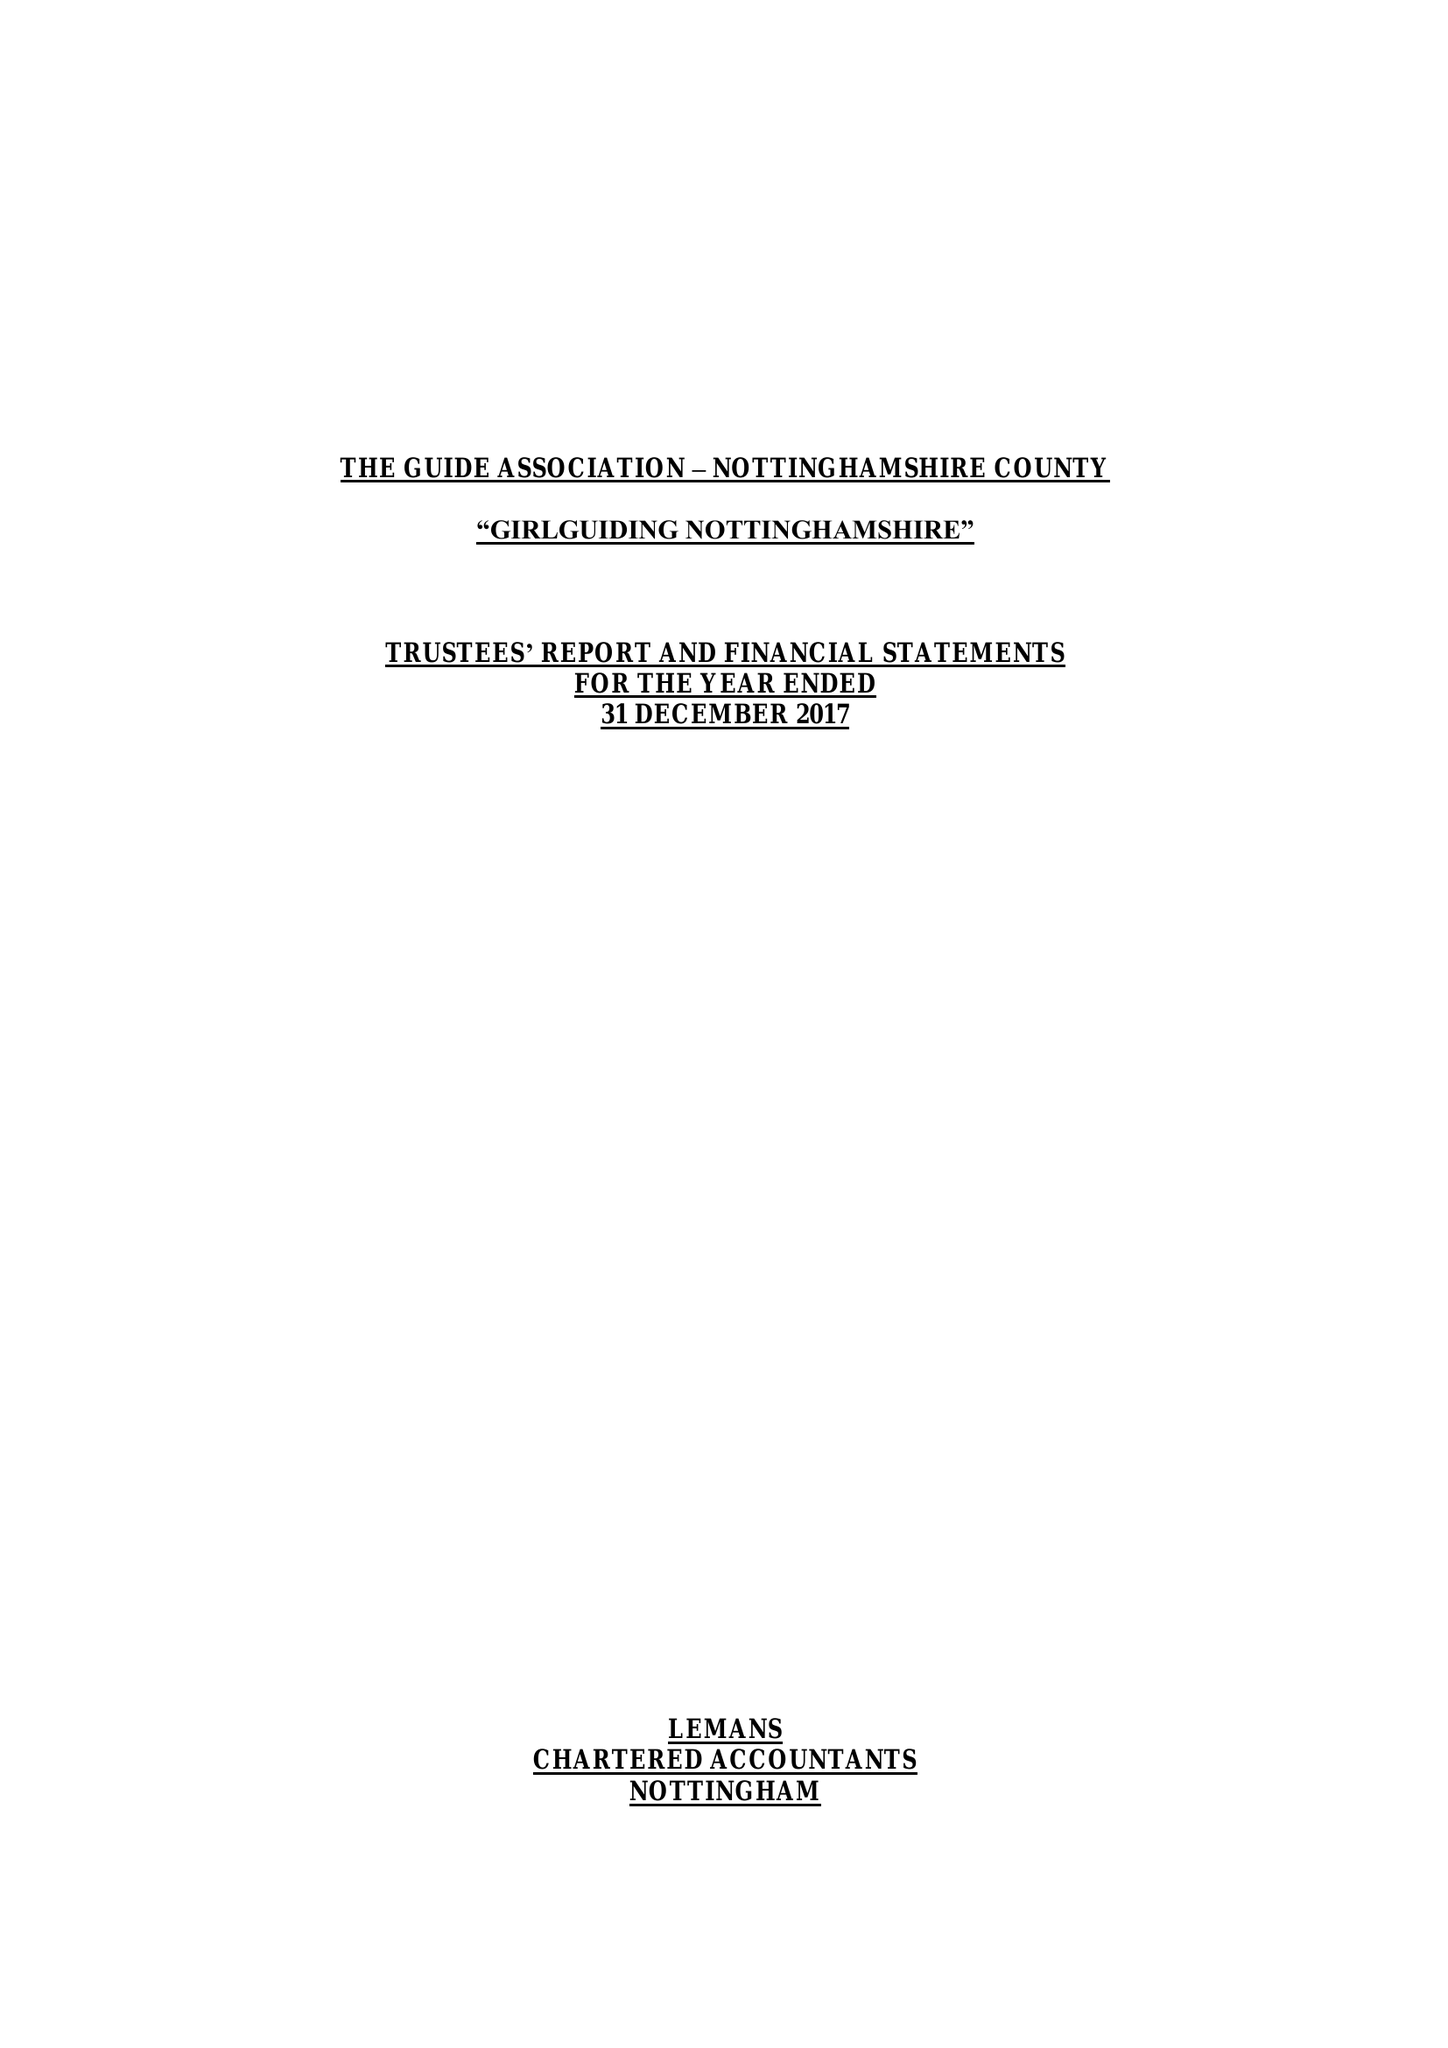What is the value for the charity_number?
Answer the question using a single word or phrase. 503168 